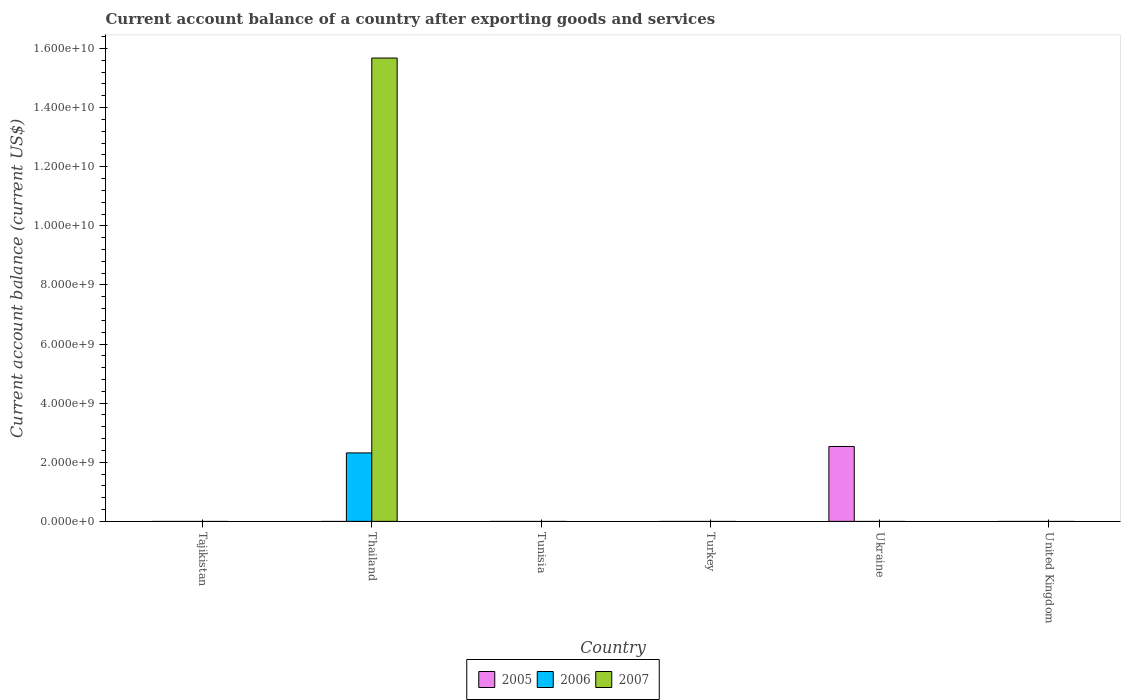Are the number of bars per tick equal to the number of legend labels?
Keep it short and to the point. No. How many bars are there on the 3rd tick from the right?
Offer a terse response. 0. What is the label of the 2nd group of bars from the left?
Provide a short and direct response. Thailand. Across all countries, what is the maximum account balance in 2007?
Give a very brief answer. 1.57e+1. In which country was the account balance in 2006 maximum?
Ensure brevity in your answer.  Thailand. What is the total account balance in 2005 in the graph?
Your response must be concise. 2.53e+09. What is the average account balance in 2007 per country?
Keep it short and to the point. 2.61e+09. In how many countries, is the account balance in 2006 greater than 13200000000 US$?
Keep it short and to the point. 0. What is the difference between the highest and the lowest account balance in 2006?
Your response must be concise. 2.32e+09. Is it the case that in every country, the sum of the account balance in 2007 and account balance in 2006 is greater than the account balance in 2005?
Offer a very short reply. No. What is the difference between two consecutive major ticks on the Y-axis?
Provide a short and direct response. 2.00e+09. How many legend labels are there?
Your response must be concise. 3. How are the legend labels stacked?
Ensure brevity in your answer.  Horizontal. What is the title of the graph?
Provide a short and direct response. Current account balance of a country after exporting goods and services. What is the label or title of the X-axis?
Make the answer very short. Country. What is the label or title of the Y-axis?
Your answer should be compact. Current account balance (current US$). What is the Current account balance (current US$) in 2005 in Tajikistan?
Offer a very short reply. 0. What is the Current account balance (current US$) in 2006 in Thailand?
Your response must be concise. 2.32e+09. What is the Current account balance (current US$) in 2007 in Thailand?
Provide a succinct answer. 1.57e+1. What is the Current account balance (current US$) of 2005 in Tunisia?
Your response must be concise. 0. What is the Current account balance (current US$) in 2007 in Tunisia?
Offer a terse response. 0. What is the Current account balance (current US$) in 2005 in Ukraine?
Provide a succinct answer. 2.53e+09. What is the Current account balance (current US$) in 2007 in Ukraine?
Make the answer very short. 0. What is the Current account balance (current US$) of 2006 in United Kingdom?
Give a very brief answer. 0. Across all countries, what is the maximum Current account balance (current US$) of 2005?
Provide a short and direct response. 2.53e+09. Across all countries, what is the maximum Current account balance (current US$) in 2006?
Provide a succinct answer. 2.32e+09. Across all countries, what is the maximum Current account balance (current US$) of 2007?
Give a very brief answer. 1.57e+1. Across all countries, what is the minimum Current account balance (current US$) of 2005?
Your response must be concise. 0. What is the total Current account balance (current US$) in 2005 in the graph?
Your answer should be compact. 2.53e+09. What is the total Current account balance (current US$) in 2006 in the graph?
Provide a short and direct response. 2.32e+09. What is the total Current account balance (current US$) of 2007 in the graph?
Keep it short and to the point. 1.57e+1. What is the average Current account balance (current US$) of 2005 per country?
Offer a terse response. 4.22e+08. What is the average Current account balance (current US$) in 2006 per country?
Offer a very short reply. 3.86e+08. What is the average Current account balance (current US$) of 2007 per country?
Your answer should be very brief. 2.61e+09. What is the difference between the Current account balance (current US$) of 2006 and Current account balance (current US$) of 2007 in Thailand?
Make the answer very short. -1.34e+1. What is the difference between the highest and the lowest Current account balance (current US$) in 2005?
Ensure brevity in your answer.  2.53e+09. What is the difference between the highest and the lowest Current account balance (current US$) in 2006?
Give a very brief answer. 2.32e+09. What is the difference between the highest and the lowest Current account balance (current US$) of 2007?
Ensure brevity in your answer.  1.57e+1. 